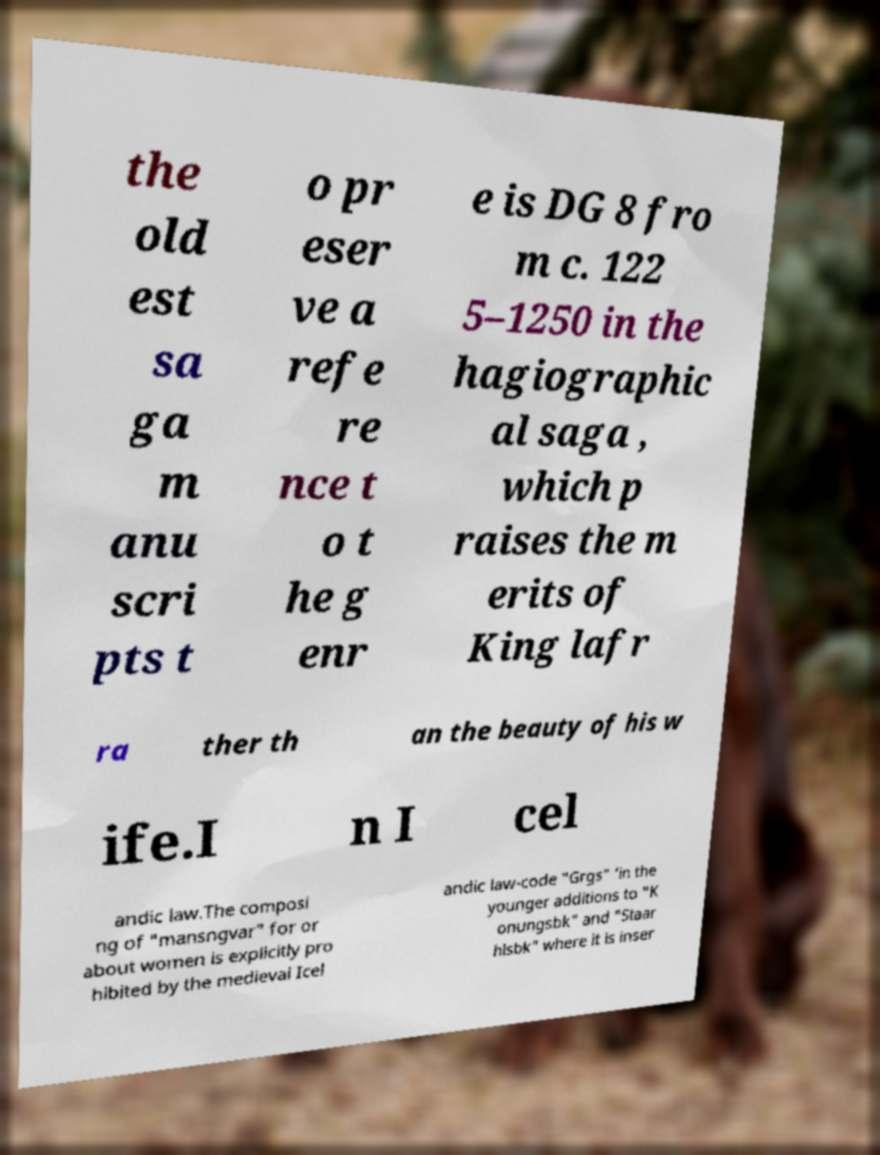Could you assist in decoding the text presented in this image and type it out clearly? the old est sa ga m anu scri pts t o pr eser ve a refe re nce t o t he g enr e is DG 8 fro m c. 122 5–1250 in the hagiographic al saga , which p raises the m erits of King lafr ra ther th an the beauty of his w ife.I n I cel andic law.The composi ng of "mansngvar" for or about women is explicitly pro hibited by the medieval Icel andic law-code "Grgs" 'in the younger additions to "K onungsbk" and "Staar hlsbk" where it is inser 